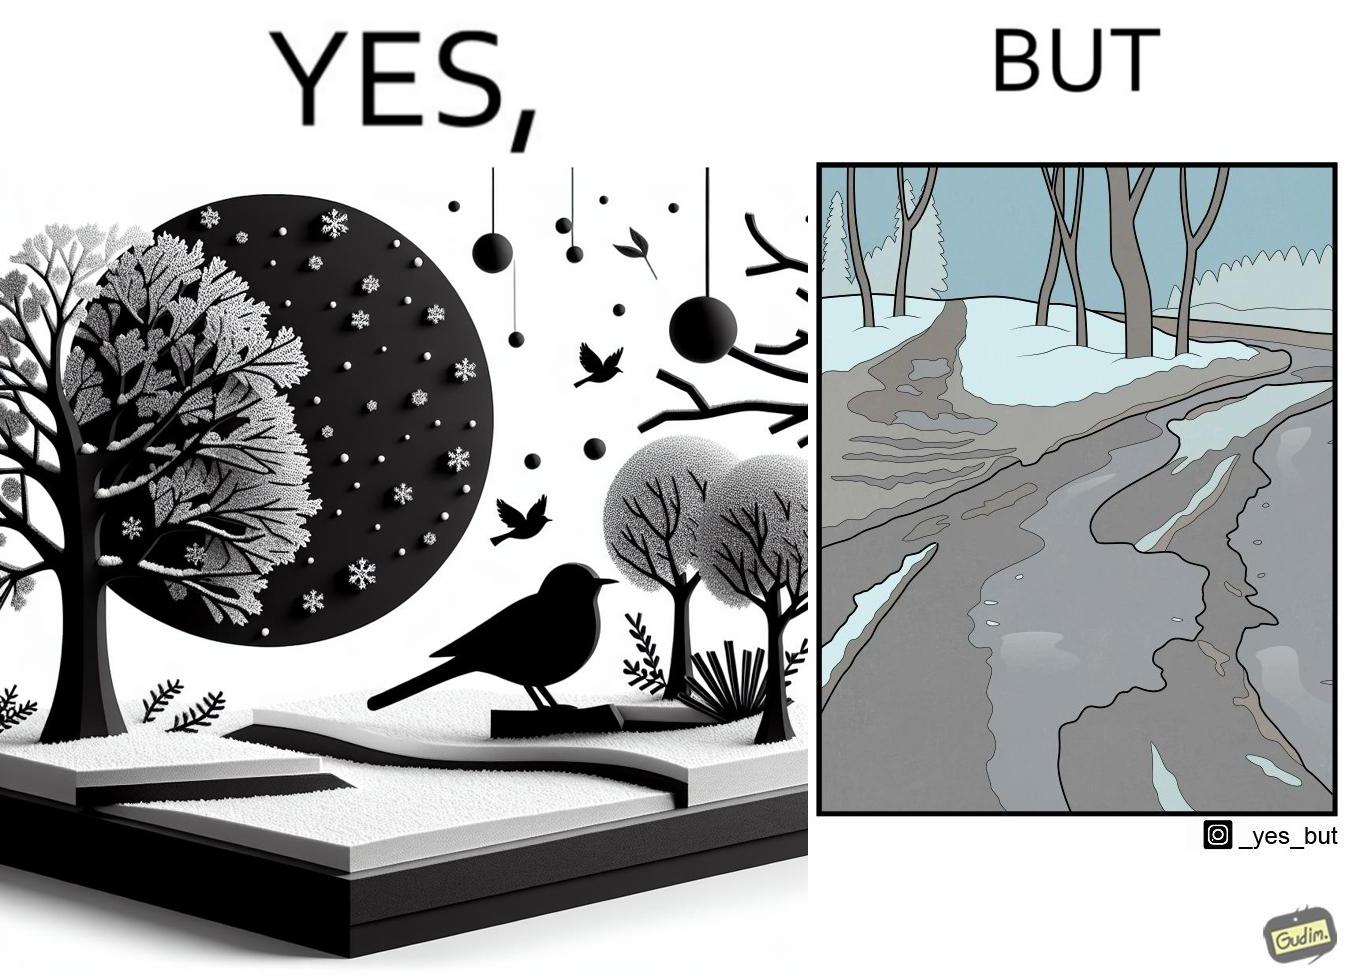What does this image depict? The image is funny, as from far, snow covered mountains look really scenic and completely white, but when zooming in near trees, the ground is partially covered in snow, and is not as scenic anymore. 